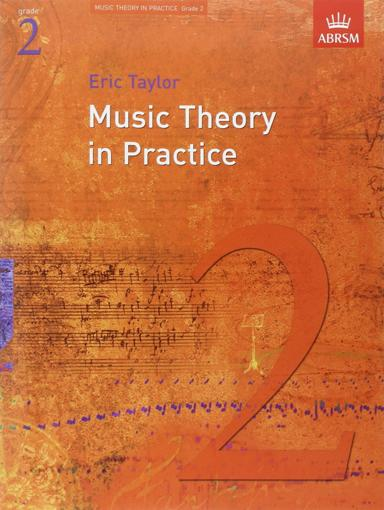Can you describe what the cover design indicates about the theme of the book? The cover features a blend of musical notes and abstract designs that suggest a focus on music theory and learning. The large number '2' indicates that this book is intended for students at a level two proficiency, which corresponds to early stages of music theory education. 